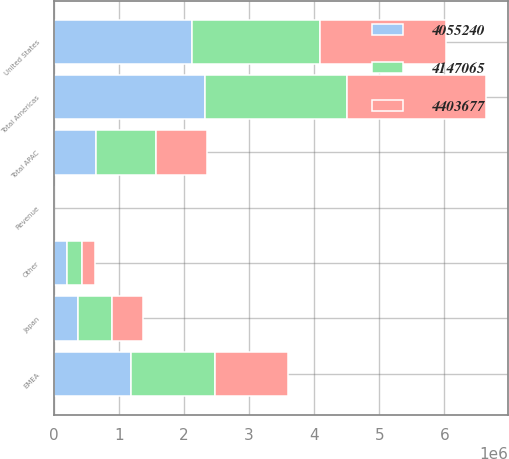Convert chart. <chart><loc_0><loc_0><loc_500><loc_500><stacked_bar_chart><ecel><fcel>Revenue<fcel>United States<fcel>Other<fcel>Total Americas<fcel>EMEA<fcel>Japan<fcel>Total APAC<nl><fcel>4.05524e+06<fcel>2014<fcel>2.11515e+06<fcel>199221<fcel>2.31437e+06<fcel>1.17986e+06<fcel>365570<fcel>652832<nl><fcel>4.40368e+06<fcel>2013<fcel>1.93543e+06<fcel>198953<fcel>2.13438e+06<fcel>1.12918e+06<fcel>472110<fcel>791678<nl><fcel>4.14706e+06<fcel>2012<fcel>1.96992e+06<fcel>226430<fcel>2.19635e+06<fcel>1.29457e+06<fcel>531028<fcel>912757<nl></chart> 